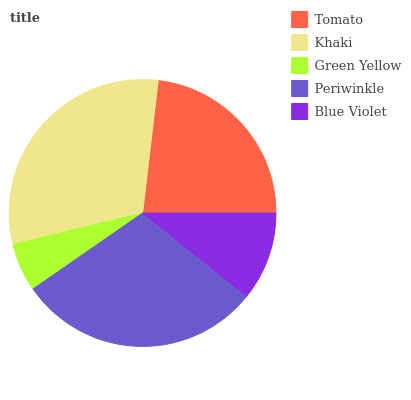Is Green Yellow the minimum?
Answer yes or no. Yes. Is Khaki the maximum?
Answer yes or no. Yes. Is Khaki the minimum?
Answer yes or no. No. Is Green Yellow the maximum?
Answer yes or no. No. Is Khaki greater than Green Yellow?
Answer yes or no. Yes. Is Green Yellow less than Khaki?
Answer yes or no. Yes. Is Green Yellow greater than Khaki?
Answer yes or no. No. Is Khaki less than Green Yellow?
Answer yes or no. No. Is Tomato the high median?
Answer yes or no. Yes. Is Tomato the low median?
Answer yes or no. Yes. Is Green Yellow the high median?
Answer yes or no. No. Is Blue Violet the low median?
Answer yes or no. No. 